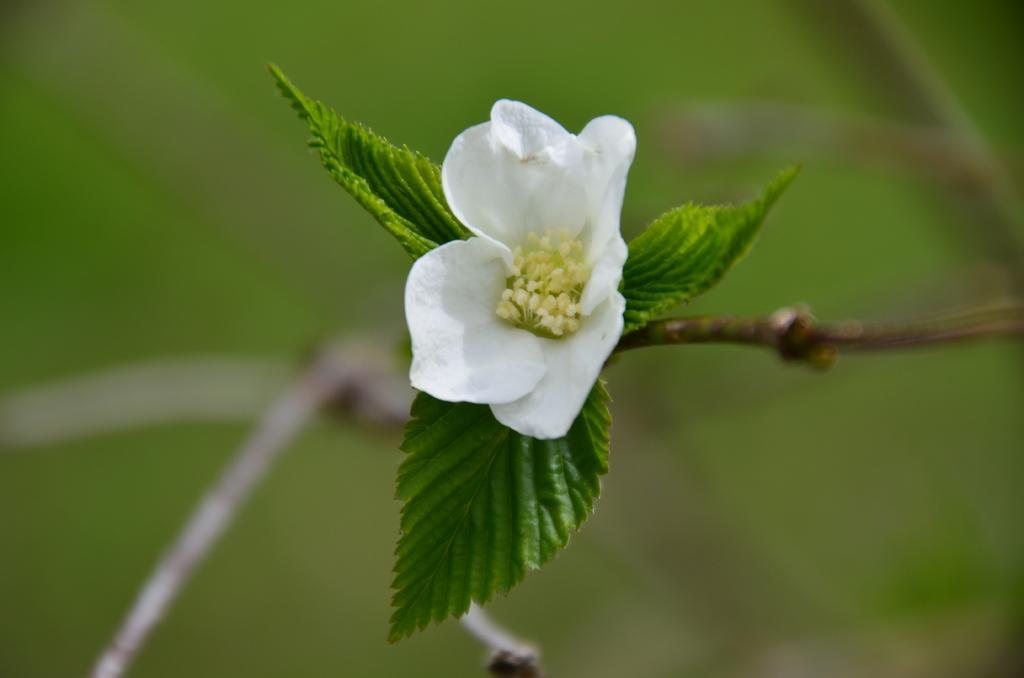In one or two sentences, can you explain what this image depicts? In the image it is a zoomin picture of a flower and leaves, the background of the flower is blue. 